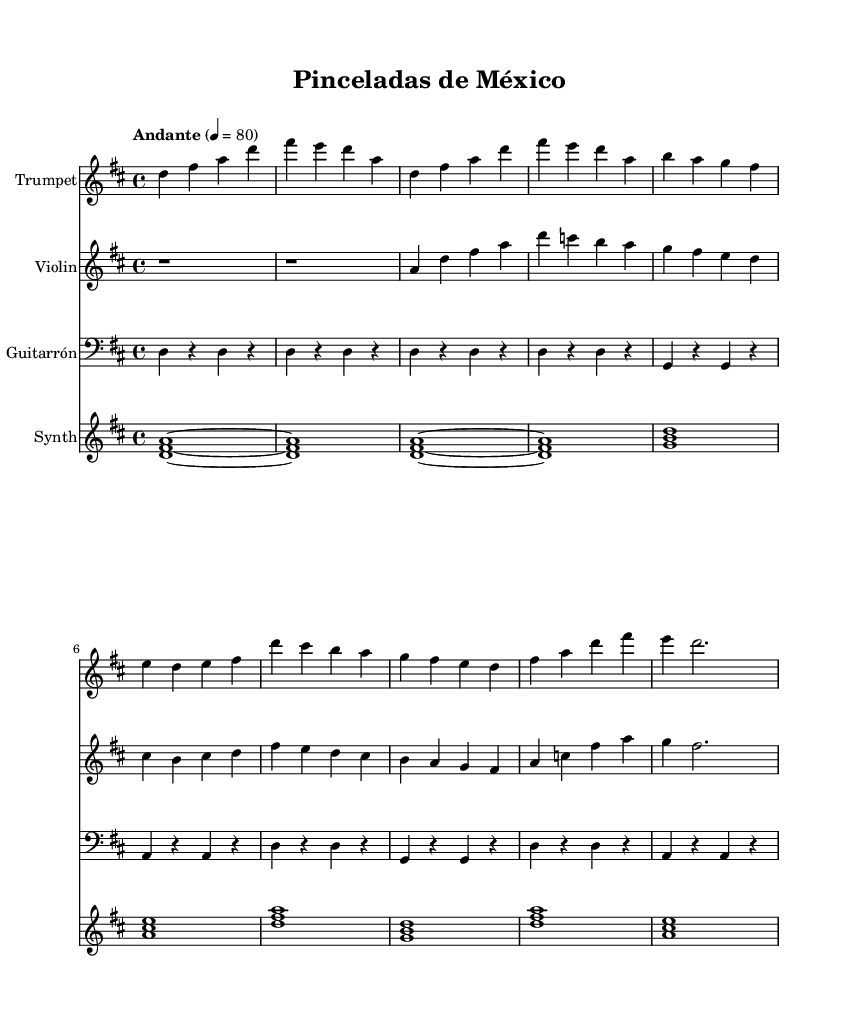what is the key signature of this music? The key signature is in D major, which has two sharps (F# and C#). This can be identified from the beginning of the music where the key is indicated.
Answer: D major what is the time signature of this music? The time signature is 4/4, meaning there are four beats per measure, with the quarter note getting one beat. This is displayed at the beginning of the score.
Answer: 4/4 what is the tempo marking for this piece? The tempo marking is "Andante", which indicates a moderately slow tempo. This is stated in the tempo indication section at the start of the music.
Answer: Andante how many instruments are featured in this score? There are four instruments featured: Trumpet, Violin, Guitarrón, and Synth. This can be counted from the staff headings shown in the score where each instrument is labeled.
Answer: Four what is the rhythmic pattern of the Guitarrón during the verse? In the verse, the Guitarrón plays a consistent pattern of quarter notes and rests. Upon analyzing the Guitarrón part, this rhythmic pattern can be deduced from its note values across the verse.
Answer: Quarter notes and rests which instruments play harmony in the chorus? The instruments that primarily play harmony in the chorus are the Trumpet and the Violin, as they provide complementary notes that support the main melody. This can be determined by examining the parts for overlapping pitches and their roles in the progression.
Answer: Trumpet and Violin what unique element does the Synth add to this composition? The Synth adds ambient soundscapes through sustained chords and atmospheric textures. This can be inferred from its relative note patterns and the use of chords that are not typical in traditional mariachi, creating a blend with ambient vibes.
Answer: Ambient soundscapes 